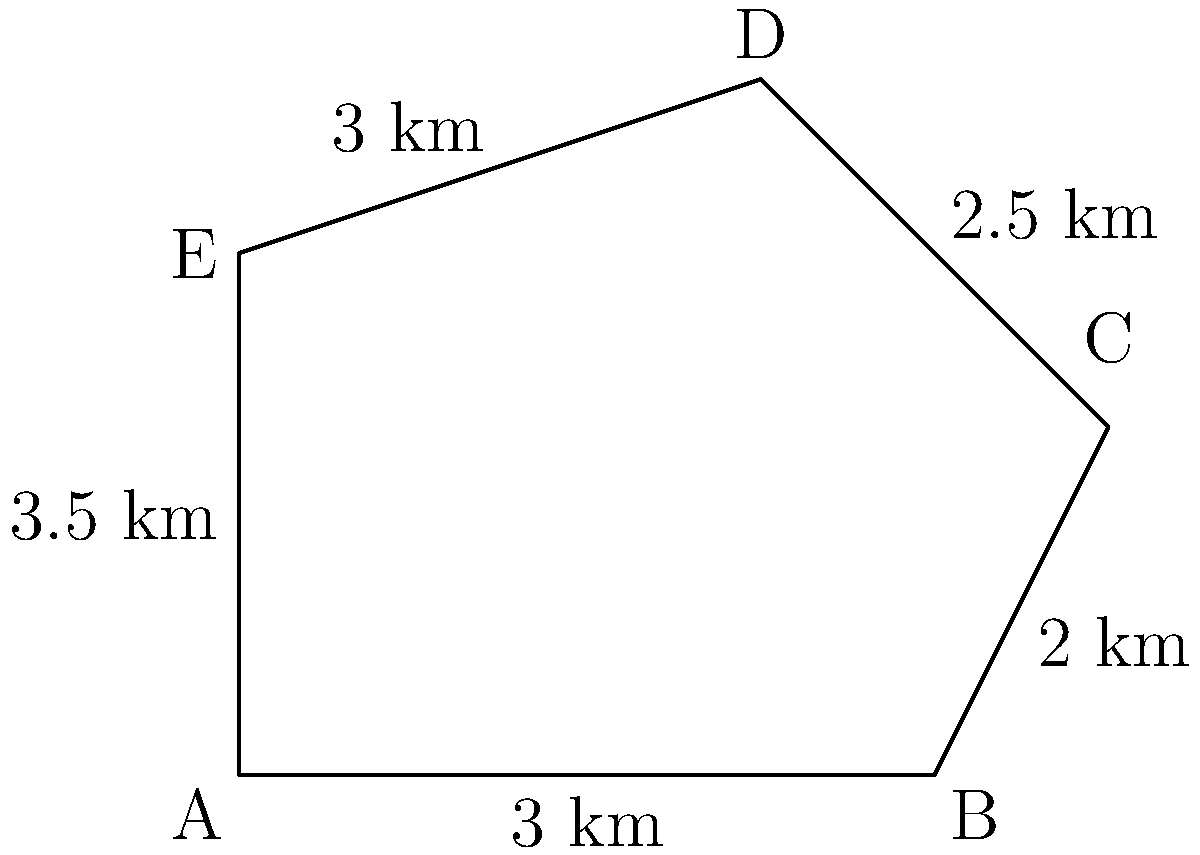As an ecologist, you're tasked with determining the perimeter of a newly established nature reserve with an irregular shape. The reserve is represented by the polygon ABCDE in the diagram. Given the distances between consecutive points as shown, calculate the total perimeter of the nature reserve in kilometers. To find the perimeter of the nature reserve, we need to sum up the distances between consecutive points along the boundary. Let's break it down step-by-step:

1. Distance AB = 3 km
2. Distance BC = 2 km
3. Distance CD = 2.5 km
4. Distance DE = 3 km
5. Distance EA = 3.5 km

Now, we simply add these distances:

$$\text{Perimeter} = AB + BC + CD + DE + EA$$
$$\text{Perimeter} = 3 + 2 + 2.5 + 3 + 3.5$$
$$\text{Perimeter} = 14 \text{ km}$$

Therefore, the total perimeter of the nature reserve is 14 kilometers.
Answer: 14 km 